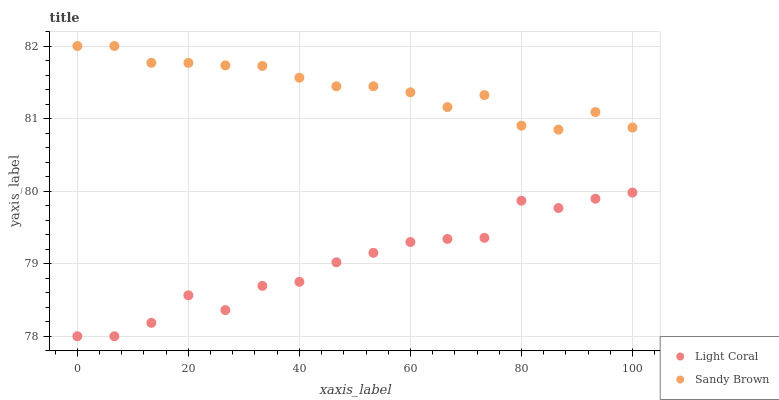Does Light Coral have the minimum area under the curve?
Answer yes or no. Yes. Does Sandy Brown have the maximum area under the curve?
Answer yes or no. Yes. Does Sandy Brown have the minimum area under the curve?
Answer yes or no. No. Is Sandy Brown the smoothest?
Answer yes or no. Yes. Is Light Coral the roughest?
Answer yes or no. Yes. Is Sandy Brown the roughest?
Answer yes or no. No. Does Light Coral have the lowest value?
Answer yes or no. Yes. Does Sandy Brown have the lowest value?
Answer yes or no. No. Does Sandy Brown have the highest value?
Answer yes or no. Yes. Is Light Coral less than Sandy Brown?
Answer yes or no. Yes. Is Sandy Brown greater than Light Coral?
Answer yes or no. Yes. Does Light Coral intersect Sandy Brown?
Answer yes or no. No. 